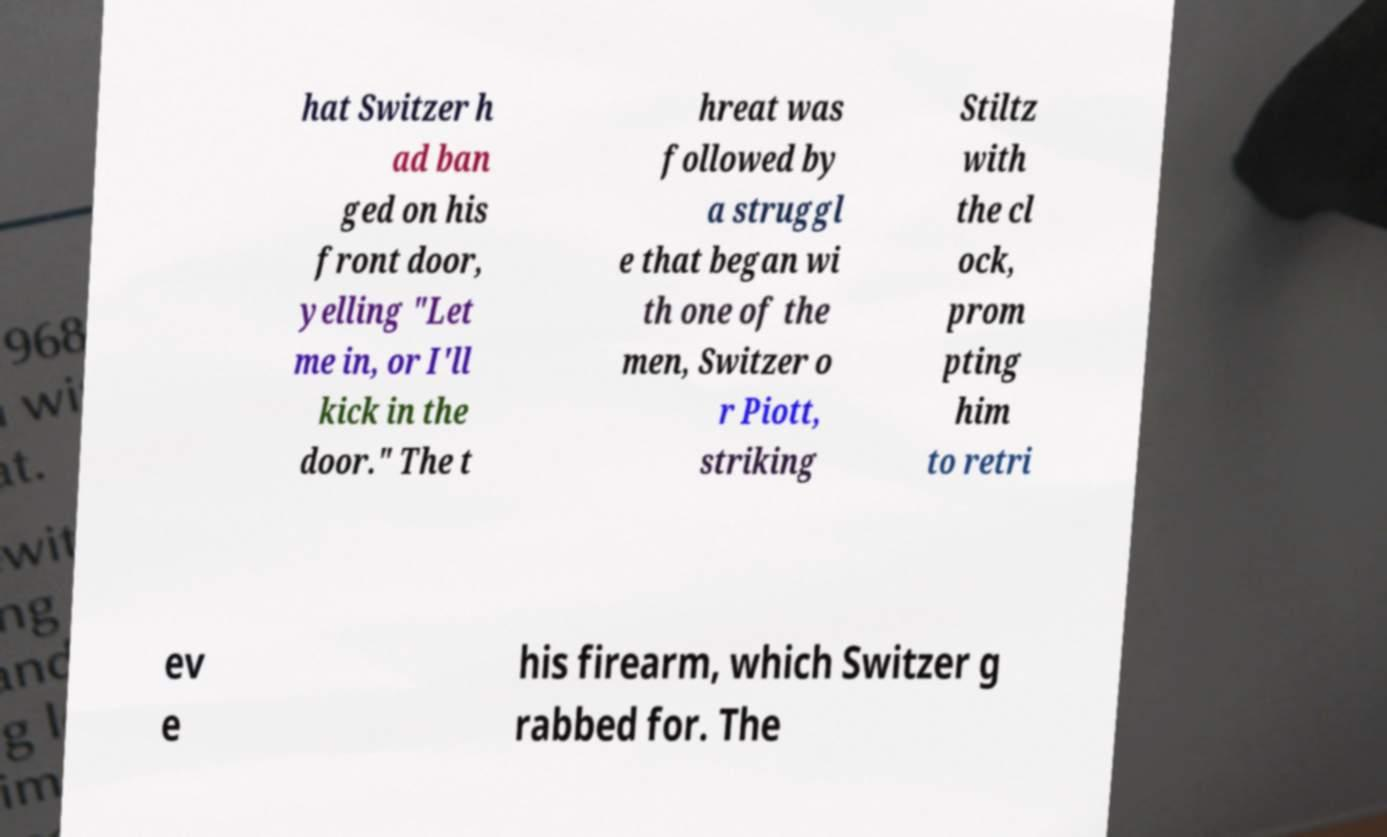Could you extract and type out the text from this image? hat Switzer h ad ban ged on his front door, yelling "Let me in, or I'll kick in the door." The t hreat was followed by a struggl e that began wi th one of the men, Switzer o r Piott, striking Stiltz with the cl ock, prom pting him to retri ev e his firearm, which Switzer g rabbed for. The 